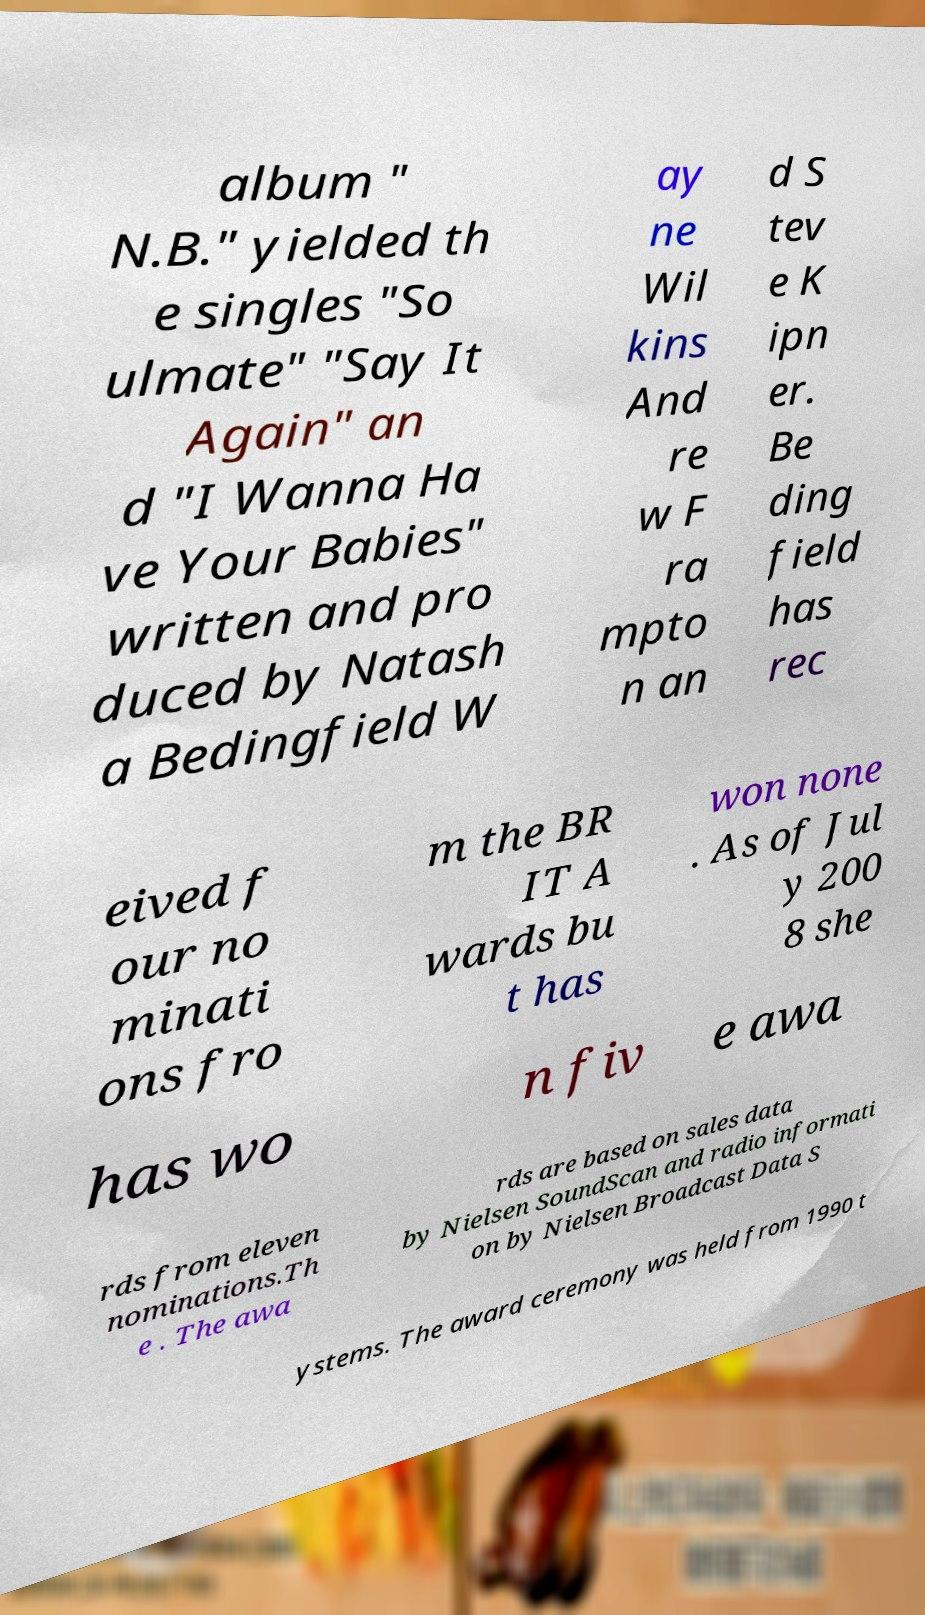Can you accurately transcribe the text from the provided image for me? album " N.B." yielded th e singles "So ulmate" "Say It Again" an d "I Wanna Ha ve Your Babies" written and pro duced by Natash a Bedingfield W ay ne Wil kins And re w F ra mpto n an d S tev e K ipn er. Be ding field has rec eived f our no minati ons fro m the BR IT A wards bu t has won none . As of Jul y 200 8 she has wo n fiv e awa rds from eleven nominations.Th e . The awa rds are based on sales data by Nielsen SoundScan and radio informati on by Nielsen Broadcast Data S ystems. The award ceremony was held from 1990 t 